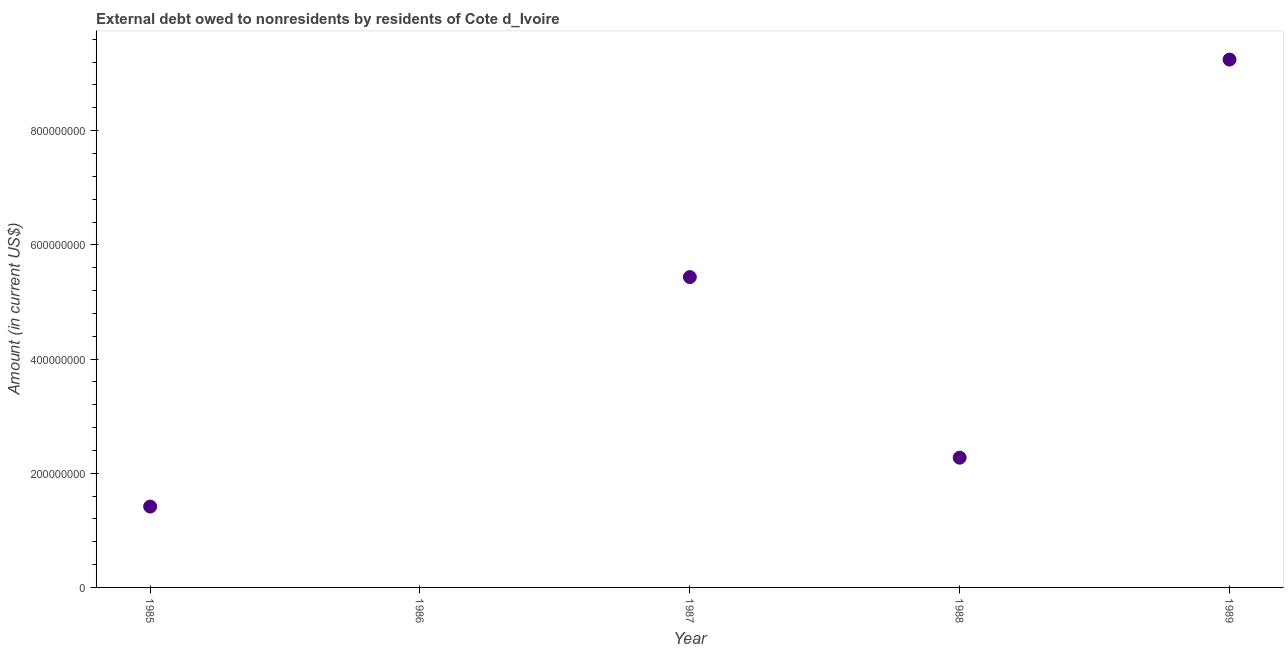What is the debt in 1988?
Provide a short and direct response. 2.27e+08. Across all years, what is the maximum debt?
Give a very brief answer. 9.24e+08. Across all years, what is the minimum debt?
Provide a succinct answer. 0. What is the sum of the debt?
Provide a short and direct response. 1.84e+09. What is the difference between the debt in 1985 and 1989?
Ensure brevity in your answer.  -7.83e+08. What is the average debt per year?
Provide a short and direct response. 3.67e+08. What is the median debt?
Provide a short and direct response. 2.27e+08. In how many years, is the debt greater than 920000000 US$?
Ensure brevity in your answer.  1. What is the ratio of the debt in 1985 to that in 1987?
Make the answer very short. 0.26. What is the difference between the highest and the second highest debt?
Provide a succinct answer. 3.81e+08. Is the sum of the debt in 1985 and 1989 greater than the maximum debt across all years?
Your answer should be compact. Yes. What is the difference between the highest and the lowest debt?
Provide a short and direct response. 9.24e+08. In how many years, is the debt greater than the average debt taken over all years?
Your answer should be compact. 2. How many dotlines are there?
Keep it short and to the point. 1. What is the difference between two consecutive major ticks on the Y-axis?
Your answer should be very brief. 2.00e+08. Are the values on the major ticks of Y-axis written in scientific E-notation?
Provide a succinct answer. No. Does the graph contain any zero values?
Provide a short and direct response. Yes. What is the title of the graph?
Ensure brevity in your answer.  External debt owed to nonresidents by residents of Cote d_Ivoire. What is the label or title of the X-axis?
Your answer should be compact. Year. What is the Amount (in current US$) in 1985?
Ensure brevity in your answer.  1.42e+08. What is the Amount (in current US$) in 1987?
Your answer should be compact. 5.44e+08. What is the Amount (in current US$) in 1988?
Your response must be concise. 2.27e+08. What is the Amount (in current US$) in 1989?
Provide a succinct answer. 9.24e+08. What is the difference between the Amount (in current US$) in 1985 and 1987?
Offer a terse response. -4.02e+08. What is the difference between the Amount (in current US$) in 1985 and 1988?
Keep it short and to the point. -8.56e+07. What is the difference between the Amount (in current US$) in 1985 and 1989?
Ensure brevity in your answer.  -7.83e+08. What is the difference between the Amount (in current US$) in 1987 and 1988?
Your response must be concise. 3.16e+08. What is the difference between the Amount (in current US$) in 1987 and 1989?
Your answer should be very brief. -3.81e+08. What is the difference between the Amount (in current US$) in 1988 and 1989?
Make the answer very short. -6.97e+08. What is the ratio of the Amount (in current US$) in 1985 to that in 1987?
Offer a terse response. 0.26. What is the ratio of the Amount (in current US$) in 1985 to that in 1988?
Your answer should be very brief. 0.62. What is the ratio of the Amount (in current US$) in 1985 to that in 1989?
Provide a short and direct response. 0.15. What is the ratio of the Amount (in current US$) in 1987 to that in 1988?
Give a very brief answer. 2.39. What is the ratio of the Amount (in current US$) in 1987 to that in 1989?
Make the answer very short. 0.59. What is the ratio of the Amount (in current US$) in 1988 to that in 1989?
Give a very brief answer. 0.25. 